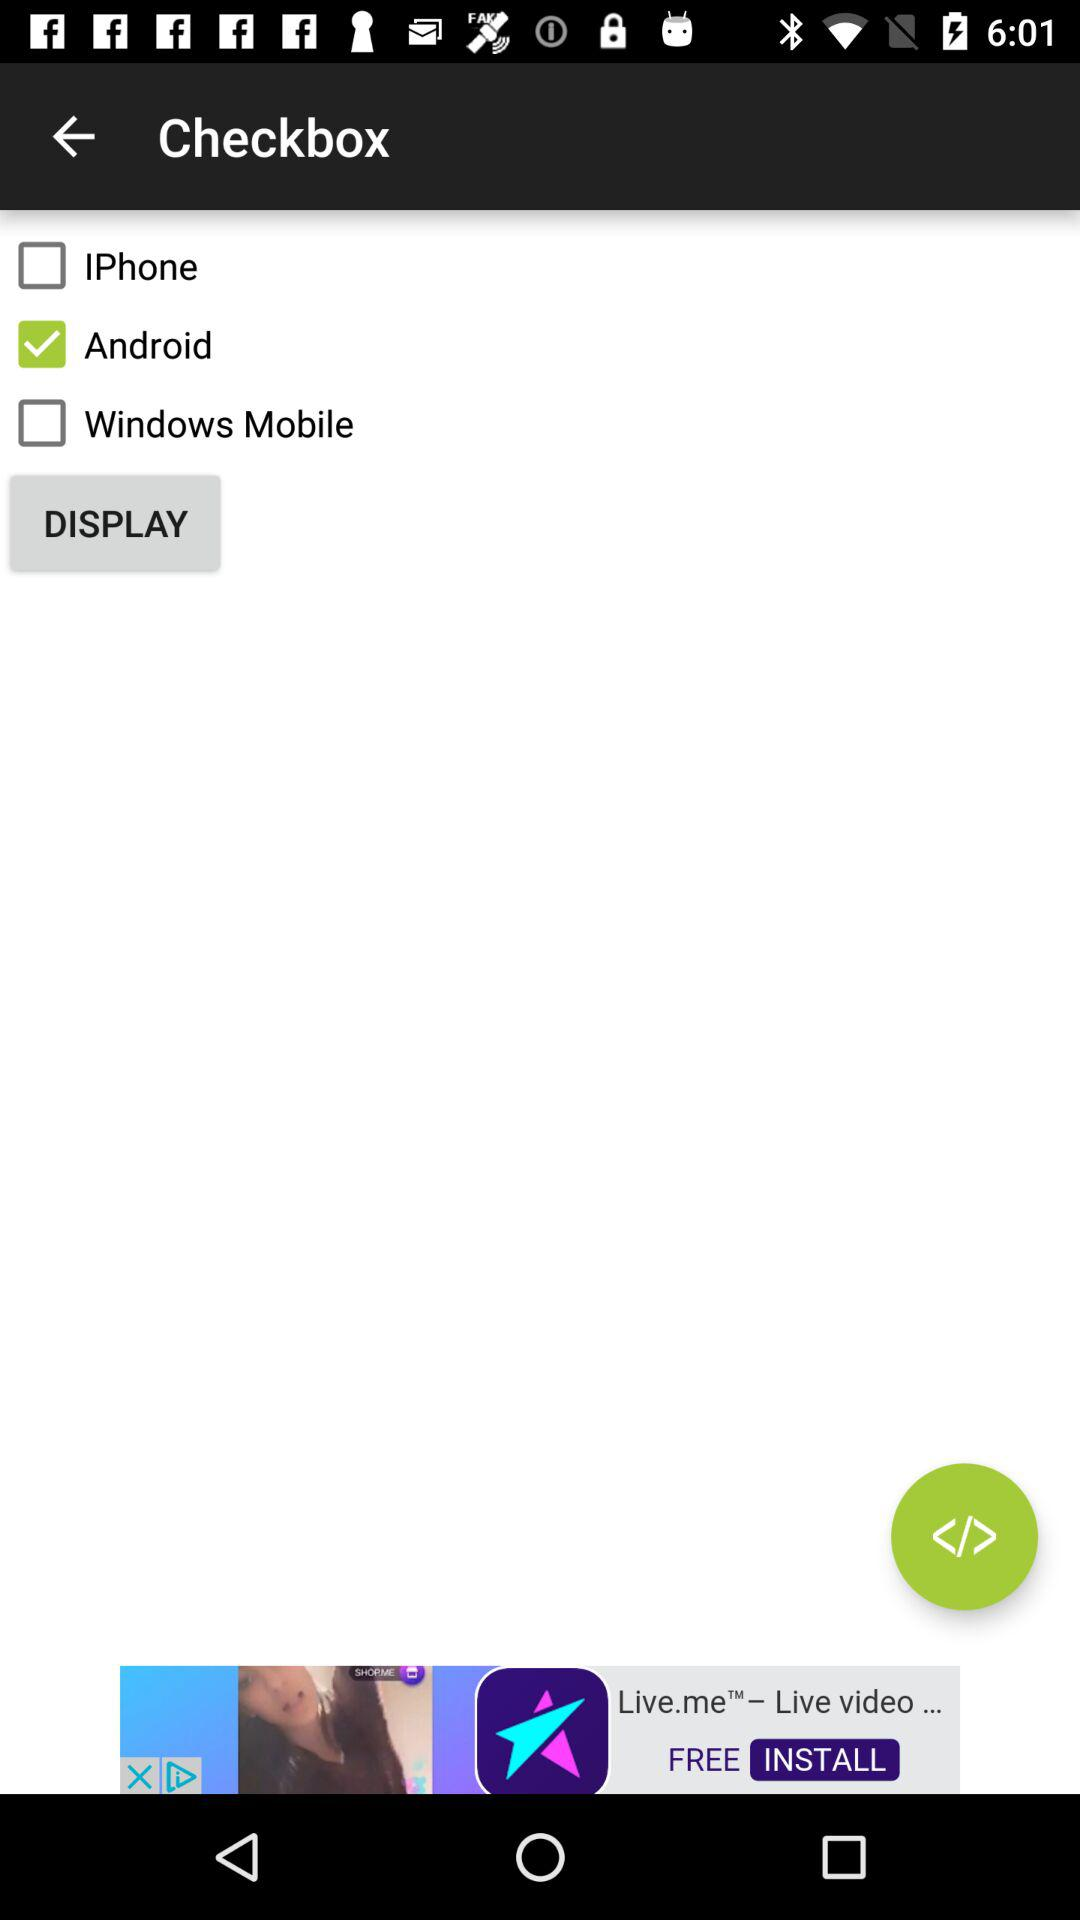Is there any indication which application or service this user interface belongs to? Based on the image alone, there is no direct indication of the specific application or service to which this user interface belongs. It seems to be a generic mobile operating system selection interface, possibly part of a setup process, a survey, or a preference configuration in an app. 